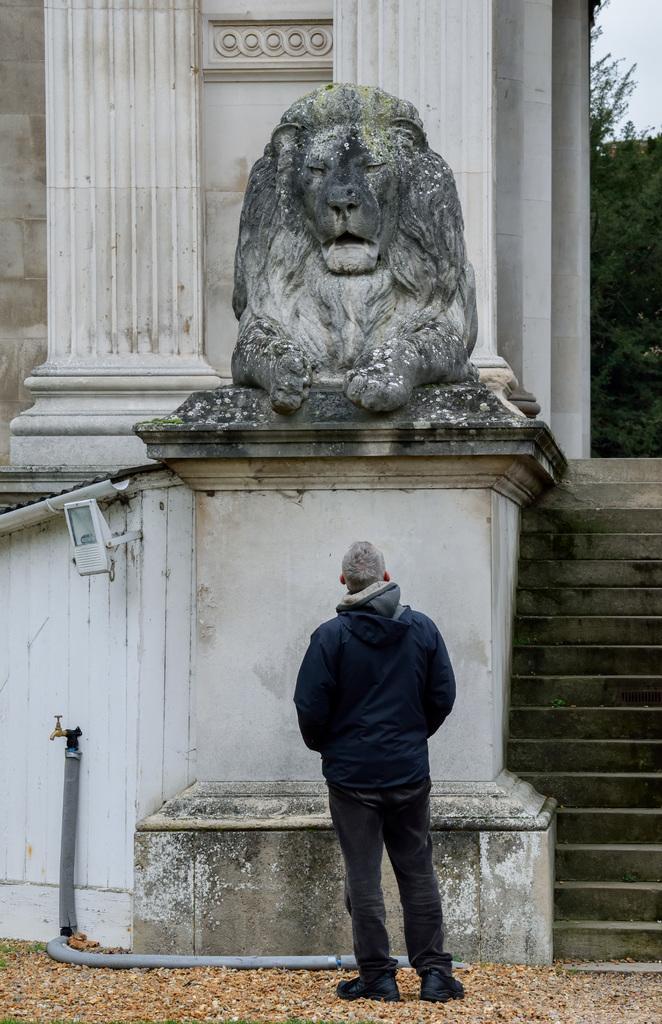How would you summarize this image in a sentence or two? In this picture I can see a person standing, there is a sculpture of a lion, there is a pipe and a tap, there are trees, at the top right corner of the image there is sky. 